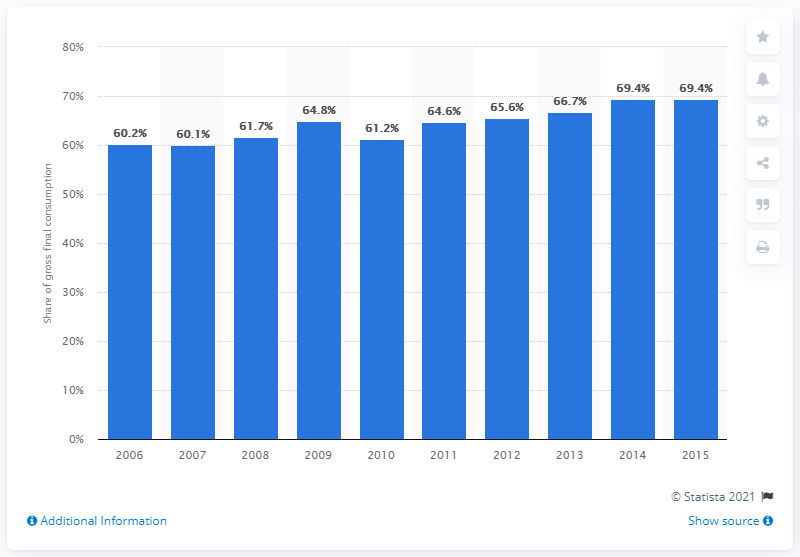Mention a couple of crucial points in this snapshot. From 2006 to 2015, the percentage of energy in Norway from renewable sources was 69.4%. During the period from 2006 to 2015, Norway's energy sources from renewable sources accounted for approximately 60.1% of the total energy production. 